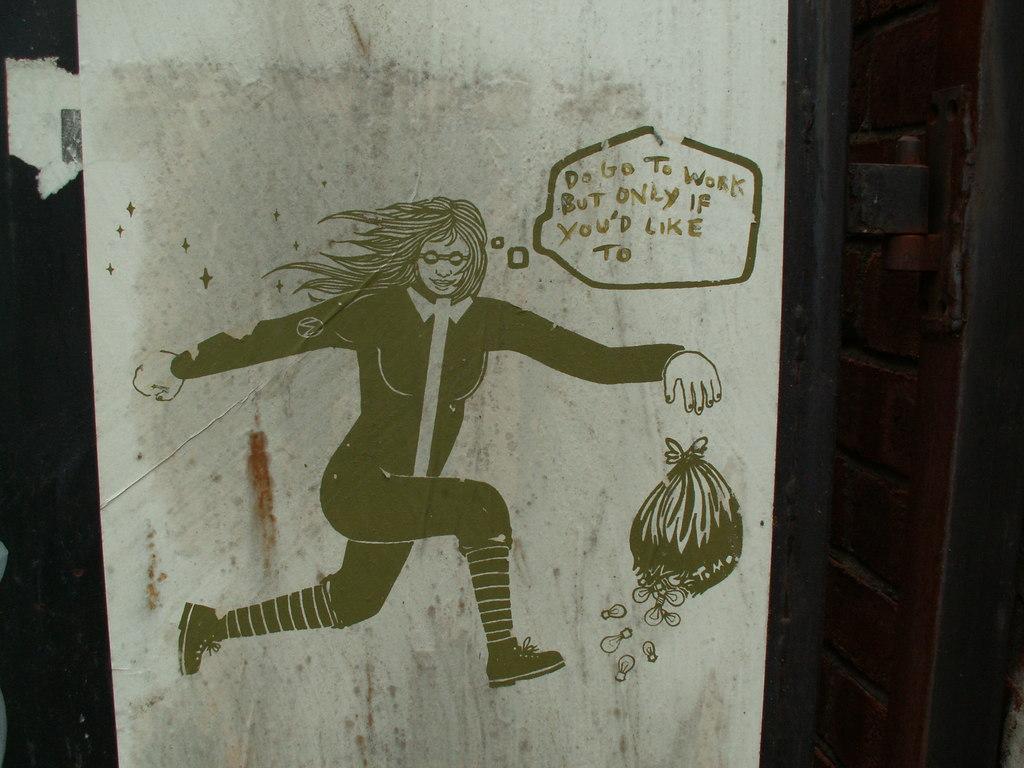Can you describe this image briefly? In this image we can see the painting of a person and a bag on the wall, also we can see the text on it. 